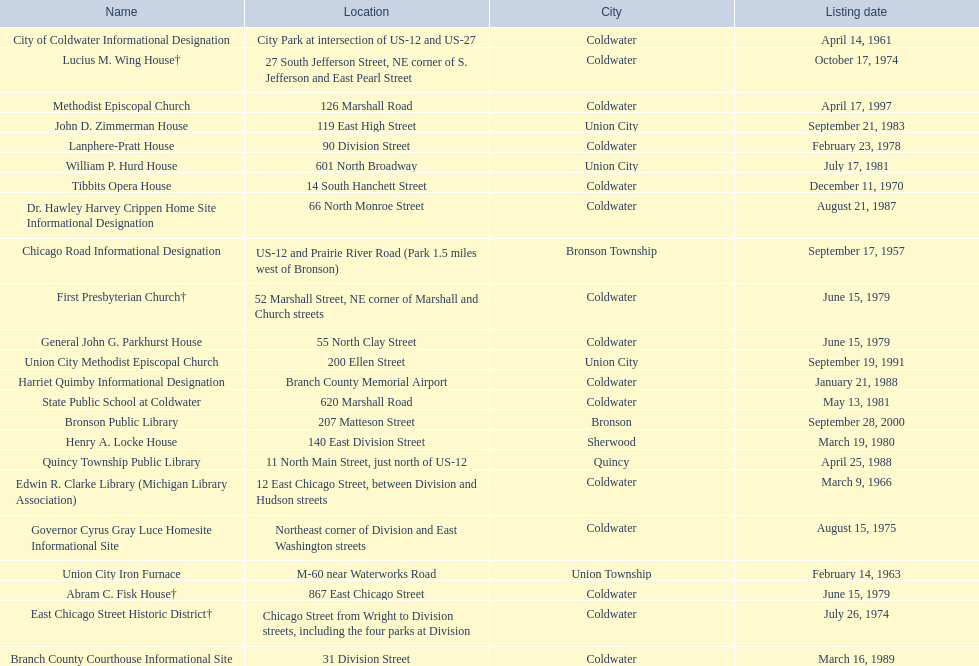How many sites were listed as historical before 1980? 12. 